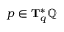Convert formula to latex. <formula><loc_0><loc_0><loc_500><loc_500>p \in T _ { q } ^ { * } \mathbb { Q }</formula> 